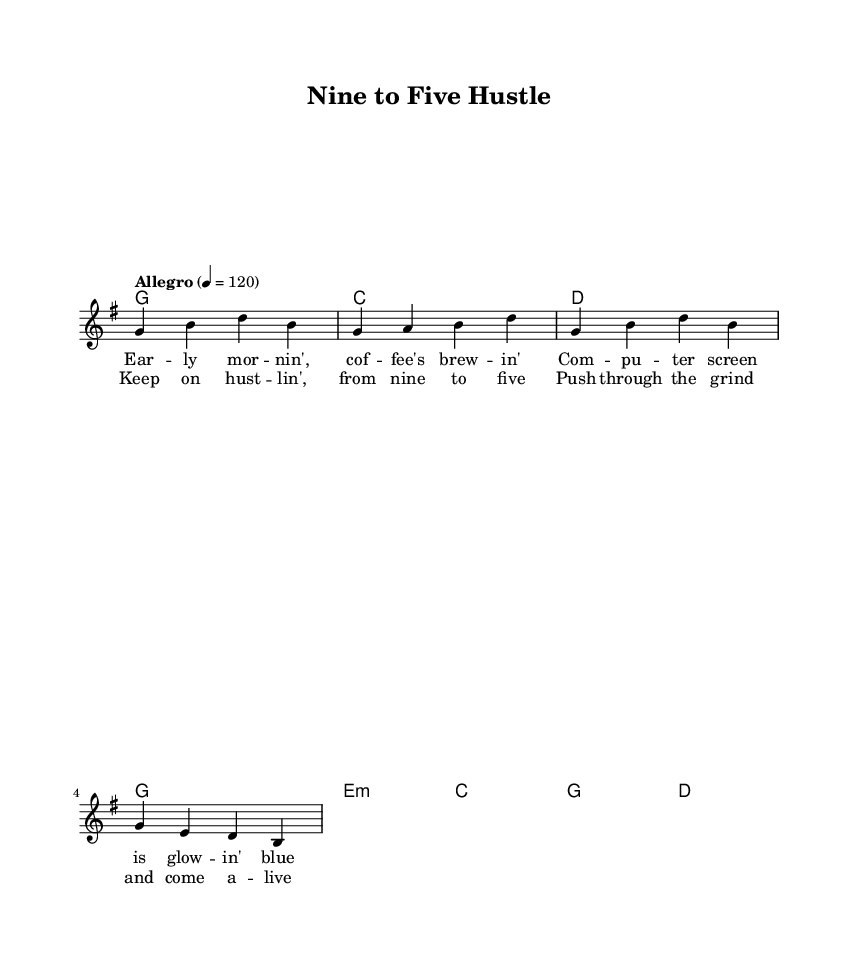What is the key signature of this music? The key signature indicated in the music is G major, which has one sharp (F#). This can be determined from the "global" section where the key is specified.
Answer: G major What is the time signature of the piece? The time signature shown is 4/4, which means there are four beats in each measure, and the quarter note gets one beat. This is also found in the "global" section of the code.
Answer: 4/4 What is the tempo marking for this anthem? The tempo marking is "Allegro," indicating a fast, lively pace, and it is set at a quarter note equal to 120 beats per minute. This is directly stated in the "global" section.
Answer: Allegro, 120 How many measures are there in the melody? Looking at the melody section, there are four measures of music provided, each ending with a bar line. Thus, counting each segment, we find a total of four measures.
Answer: 4 What type of song structure is present in this anthem? This piece has both verses and a chorus as indicated by the labels in the lyrics section. This reflects a common country song structure where verses alternate with a repeated chorus.
Answer: Verse and chorus What is the primary theme conveyed in the lyrics? The lyrics focus on motivation and perseverance through long workdays, as suggested by phrases like "Keep on hustlin', from nine to five." This aligns with the theme of staying productive and upbeat during challenging times.
Answer: Motivation 